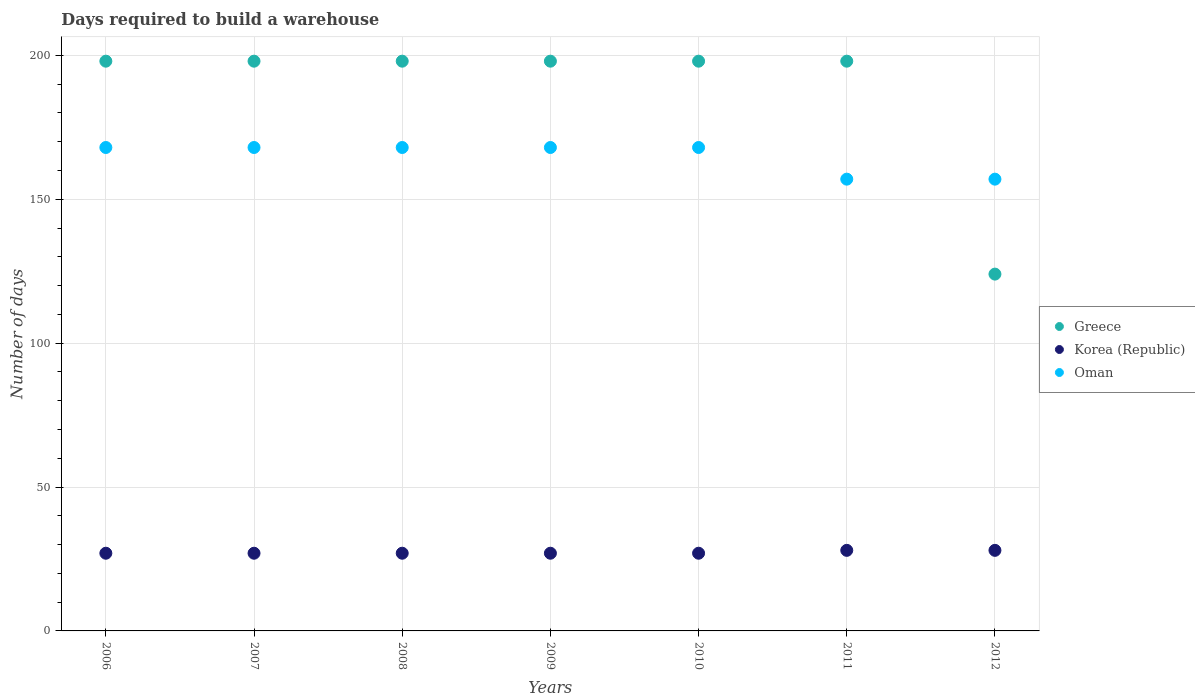How many different coloured dotlines are there?
Your response must be concise. 3. Is the number of dotlines equal to the number of legend labels?
Offer a very short reply. Yes. What is the days required to build a warehouse in in Korea (Republic) in 2009?
Provide a succinct answer. 27. Across all years, what is the maximum days required to build a warehouse in in Oman?
Give a very brief answer. 168. Across all years, what is the minimum days required to build a warehouse in in Greece?
Your answer should be compact. 124. What is the total days required to build a warehouse in in Oman in the graph?
Give a very brief answer. 1154. What is the difference between the days required to build a warehouse in in Greece in 2006 and that in 2010?
Ensure brevity in your answer.  0. What is the difference between the days required to build a warehouse in in Korea (Republic) in 2011 and the days required to build a warehouse in in Oman in 2009?
Make the answer very short. -140. What is the average days required to build a warehouse in in Greece per year?
Offer a terse response. 187.43. In the year 2008, what is the difference between the days required to build a warehouse in in Oman and days required to build a warehouse in in Greece?
Offer a terse response. -30. In how many years, is the days required to build a warehouse in in Greece greater than 40 days?
Provide a short and direct response. 7. What is the ratio of the days required to build a warehouse in in Korea (Republic) in 2007 to that in 2012?
Make the answer very short. 0.96. Is the days required to build a warehouse in in Greece in 2011 less than that in 2012?
Offer a terse response. No. Is the difference between the days required to build a warehouse in in Oman in 2006 and 2011 greater than the difference between the days required to build a warehouse in in Greece in 2006 and 2011?
Provide a short and direct response. Yes. What is the difference between the highest and the second highest days required to build a warehouse in in Korea (Republic)?
Your response must be concise. 0. What is the difference between the highest and the lowest days required to build a warehouse in in Korea (Republic)?
Provide a short and direct response. 1. In how many years, is the days required to build a warehouse in in Korea (Republic) greater than the average days required to build a warehouse in in Korea (Republic) taken over all years?
Keep it short and to the point. 2. Is the sum of the days required to build a warehouse in in Oman in 2008 and 2011 greater than the maximum days required to build a warehouse in in Greece across all years?
Ensure brevity in your answer.  Yes. Is it the case that in every year, the sum of the days required to build a warehouse in in Oman and days required to build a warehouse in in Korea (Republic)  is greater than the days required to build a warehouse in in Greece?
Your response must be concise. No. Is the days required to build a warehouse in in Oman strictly greater than the days required to build a warehouse in in Korea (Republic) over the years?
Keep it short and to the point. Yes. How many dotlines are there?
Offer a terse response. 3. How many years are there in the graph?
Your response must be concise. 7. Does the graph contain any zero values?
Your answer should be very brief. No. Where does the legend appear in the graph?
Make the answer very short. Center right. How are the legend labels stacked?
Ensure brevity in your answer.  Vertical. What is the title of the graph?
Your answer should be compact. Days required to build a warehouse. Does "Brazil" appear as one of the legend labels in the graph?
Provide a short and direct response. No. What is the label or title of the X-axis?
Provide a short and direct response. Years. What is the label or title of the Y-axis?
Your answer should be very brief. Number of days. What is the Number of days in Greece in 2006?
Your answer should be very brief. 198. What is the Number of days of Korea (Republic) in 2006?
Your answer should be very brief. 27. What is the Number of days of Oman in 2006?
Keep it short and to the point. 168. What is the Number of days of Greece in 2007?
Your response must be concise. 198. What is the Number of days of Korea (Republic) in 2007?
Give a very brief answer. 27. What is the Number of days of Oman in 2007?
Your answer should be compact. 168. What is the Number of days of Greece in 2008?
Your answer should be compact. 198. What is the Number of days of Korea (Republic) in 2008?
Offer a very short reply. 27. What is the Number of days in Oman in 2008?
Provide a succinct answer. 168. What is the Number of days in Greece in 2009?
Make the answer very short. 198. What is the Number of days of Oman in 2009?
Your response must be concise. 168. What is the Number of days of Greece in 2010?
Give a very brief answer. 198. What is the Number of days of Oman in 2010?
Keep it short and to the point. 168. What is the Number of days of Greece in 2011?
Your answer should be very brief. 198. What is the Number of days of Korea (Republic) in 2011?
Offer a very short reply. 28. What is the Number of days in Oman in 2011?
Give a very brief answer. 157. What is the Number of days of Greece in 2012?
Provide a short and direct response. 124. What is the Number of days in Oman in 2012?
Offer a very short reply. 157. Across all years, what is the maximum Number of days in Greece?
Make the answer very short. 198. Across all years, what is the maximum Number of days of Korea (Republic)?
Offer a very short reply. 28. Across all years, what is the maximum Number of days in Oman?
Offer a very short reply. 168. Across all years, what is the minimum Number of days in Greece?
Keep it short and to the point. 124. Across all years, what is the minimum Number of days of Oman?
Ensure brevity in your answer.  157. What is the total Number of days of Greece in the graph?
Ensure brevity in your answer.  1312. What is the total Number of days in Korea (Republic) in the graph?
Offer a terse response. 191. What is the total Number of days in Oman in the graph?
Offer a terse response. 1154. What is the difference between the Number of days in Korea (Republic) in 2006 and that in 2007?
Ensure brevity in your answer.  0. What is the difference between the Number of days in Korea (Republic) in 2006 and that in 2008?
Your answer should be compact. 0. What is the difference between the Number of days in Oman in 2006 and that in 2008?
Your response must be concise. 0. What is the difference between the Number of days of Oman in 2006 and that in 2009?
Ensure brevity in your answer.  0. What is the difference between the Number of days in Greece in 2006 and that in 2010?
Offer a very short reply. 0. What is the difference between the Number of days in Oman in 2006 and that in 2010?
Provide a succinct answer. 0. What is the difference between the Number of days in Greece in 2006 and that in 2011?
Offer a terse response. 0. What is the difference between the Number of days in Greece in 2006 and that in 2012?
Make the answer very short. 74. What is the difference between the Number of days of Korea (Republic) in 2006 and that in 2012?
Offer a very short reply. -1. What is the difference between the Number of days in Oman in 2006 and that in 2012?
Ensure brevity in your answer.  11. What is the difference between the Number of days in Oman in 2007 and that in 2008?
Make the answer very short. 0. What is the difference between the Number of days of Korea (Republic) in 2007 and that in 2009?
Make the answer very short. 0. What is the difference between the Number of days in Oman in 2007 and that in 2010?
Keep it short and to the point. 0. What is the difference between the Number of days of Korea (Republic) in 2007 and that in 2011?
Offer a terse response. -1. What is the difference between the Number of days of Oman in 2007 and that in 2011?
Your answer should be very brief. 11. What is the difference between the Number of days of Greece in 2007 and that in 2012?
Ensure brevity in your answer.  74. What is the difference between the Number of days in Oman in 2007 and that in 2012?
Ensure brevity in your answer.  11. What is the difference between the Number of days in Oman in 2008 and that in 2009?
Your response must be concise. 0. What is the difference between the Number of days of Korea (Republic) in 2008 and that in 2010?
Your response must be concise. 0. What is the difference between the Number of days of Oman in 2008 and that in 2010?
Offer a terse response. 0. What is the difference between the Number of days in Greece in 2008 and that in 2011?
Provide a short and direct response. 0. What is the difference between the Number of days in Oman in 2008 and that in 2012?
Provide a succinct answer. 11. What is the difference between the Number of days of Korea (Republic) in 2009 and that in 2010?
Ensure brevity in your answer.  0. What is the difference between the Number of days in Oman in 2009 and that in 2010?
Your answer should be compact. 0. What is the difference between the Number of days of Greece in 2009 and that in 2011?
Offer a very short reply. 0. What is the difference between the Number of days in Oman in 2009 and that in 2011?
Give a very brief answer. 11. What is the difference between the Number of days in Greece in 2009 and that in 2012?
Keep it short and to the point. 74. What is the difference between the Number of days in Korea (Republic) in 2009 and that in 2012?
Offer a terse response. -1. What is the difference between the Number of days of Greece in 2010 and that in 2011?
Your answer should be compact. 0. What is the difference between the Number of days in Korea (Republic) in 2010 and that in 2012?
Provide a succinct answer. -1. What is the difference between the Number of days of Oman in 2010 and that in 2012?
Your answer should be compact. 11. What is the difference between the Number of days of Korea (Republic) in 2011 and that in 2012?
Offer a terse response. 0. What is the difference between the Number of days in Greece in 2006 and the Number of days in Korea (Republic) in 2007?
Offer a very short reply. 171. What is the difference between the Number of days of Korea (Republic) in 2006 and the Number of days of Oman in 2007?
Make the answer very short. -141. What is the difference between the Number of days in Greece in 2006 and the Number of days in Korea (Republic) in 2008?
Your response must be concise. 171. What is the difference between the Number of days in Greece in 2006 and the Number of days in Oman in 2008?
Your answer should be very brief. 30. What is the difference between the Number of days in Korea (Republic) in 2006 and the Number of days in Oman in 2008?
Provide a short and direct response. -141. What is the difference between the Number of days of Greece in 2006 and the Number of days of Korea (Republic) in 2009?
Your answer should be very brief. 171. What is the difference between the Number of days in Greece in 2006 and the Number of days in Oman in 2009?
Provide a short and direct response. 30. What is the difference between the Number of days in Korea (Republic) in 2006 and the Number of days in Oman in 2009?
Your answer should be very brief. -141. What is the difference between the Number of days of Greece in 2006 and the Number of days of Korea (Republic) in 2010?
Your response must be concise. 171. What is the difference between the Number of days of Greece in 2006 and the Number of days of Oman in 2010?
Offer a terse response. 30. What is the difference between the Number of days of Korea (Republic) in 2006 and the Number of days of Oman in 2010?
Your answer should be compact. -141. What is the difference between the Number of days in Greece in 2006 and the Number of days in Korea (Republic) in 2011?
Your response must be concise. 170. What is the difference between the Number of days in Greece in 2006 and the Number of days in Oman in 2011?
Your answer should be very brief. 41. What is the difference between the Number of days of Korea (Republic) in 2006 and the Number of days of Oman in 2011?
Your response must be concise. -130. What is the difference between the Number of days of Greece in 2006 and the Number of days of Korea (Republic) in 2012?
Provide a short and direct response. 170. What is the difference between the Number of days of Greece in 2006 and the Number of days of Oman in 2012?
Provide a succinct answer. 41. What is the difference between the Number of days in Korea (Republic) in 2006 and the Number of days in Oman in 2012?
Provide a succinct answer. -130. What is the difference between the Number of days in Greece in 2007 and the Number of days in Korea (Republic) in 2008?
Your answer should be compact. 171. What is the difference between the Number of days in Greece in 2007 and the Number of days in Oman in 2008?
Keep it short and to the point. 30. What is the difference between the Number of days in Korea (Republic) in 2007 and the Number of days in Oman in 2008?
Provide a succinct answer. -141. What is the difference between the Number of days of Greece in 2007 and the Number of days of Korea (Republic) in 2009?
Give a very brief answer. 171. What is the difference between the Number of days of Korea (Republic) in 2007 and the Number of days of Oman in 2009?
Provide a succinct answer. -141. What is the difference between the Number of days in Greece in 2007 and the Number of days in Korea (Republic) in 2010?
Ensure brevity in your answer.  171. What is the difference between the Number of days in Greece in 2007 and the Number of days in Oman in 2010?
Offer a very short reply. 30. What is the difference between the Number of days in Korea (Republic) in 2007 and the Number of days in Oman in 2010?
Make the answer very short. -141. What is the difference between the Number of days in Greece in 2007 and the Number of days in Korea (Republic) in 2011?
Your response must be concise. 170. What is the difference between the Number of days of Korea (Republic) in 2007 and the Number of days of Oman in 2011?
Your answer should be compact. -130. What is the difference between the Number of days in Greece in 2007 and the Number of days in Korea (Republic) in 2012?
Your answer should be compact. 170. What is the difference between the Number of days of Greece in 2007 and the Number of days of Oman in 2012?
Offer a very short reply. 41. What is the difference between the Number of days in Korea (Republic) in 2007 and the Number of days in Oman in 2012?
Make the answer very short. -130. What is the difference between the Number of days in Greece in 2008 and the Number of days in Korea (Republic) in 2009?
Offer a very short reply. 171. What is the difference between the Number of days in Greece in 2008 and the Number of days in Oman in 2009?
Offer a very short reply. 30. What is the difference between the Number of days in Korea (Republic) in 2008 and the Number of days in Oman in 2009?
Make the answer very short. -141. What is the difference between the Number of days in Greece in 2008 and the Number of days in Korea (Republic) in 2010?
Your answer should be very brief. 171. What is the difference between the Number of days in Greece in 2008 and the Number of days in Oman in 2010?
Make the answer very short. 30. What is the difference between the Number of days of Korea (Republic) in 2008 and the Number of days of Oman in 2010?
Provide a succinct answer. -141. What is the difference between the Number of days in Greece in 2008 and the Number of days in Korea (Republic) in 2011?
Provide a succinct answer. 170. What is the difference between the Number of days of Greece in 2008 and the Number of days of Oman in 2011?
Your answer should be very brief. 41. What is the difference between the Number of days in Korea (Republic) in 2008 and the Number of days in Oman in 2011?
Make the answer very short. -130. What is the difference between the Number of days of Greece in 2008 and the Number of days of Korea (Republic) in 2012?
Provide a succinct answer. 170. What is the difference between the Number of days of Greece in 2008 and the Number of days of Oman in 2012?
Your answer should be very brief. 41. What is the difference between the Number of days in Korea (Republic) in 2008 and the Number of days in Oman in 2012?
Ensure brevity in your answer.  -130. What is the difference between the Number of days of Greece in 2009 and the Number of days of Korea (Republic) in 2010?
Your response must be concise. 171. What is the difference between the Number of days in Greece in 2009 and the Number of days in Oman in 2010?
Ensure brevity in your answer.  30. What is the difference between the Number of days of Korea (Republic) in 2009 and the Number of days of Oman in 2010?
Your answer should be compact. -141. What is the difference between the Number of days in Greece in 2009 and the Number of days in Korea (Republic) in 2011?
Ensure brevity in your answer.  170. What is the difference between the Number of days of Greece in 2009 and the Number of days of Oman in 2011?
Keep it short and to the point. 41. What is the difference between the Number of days in Korea (Republic) in 2009 and the Number of days in Oman in 2011?
Your answer should be very brief. -130. What is the difference between the Number of days in Greece in 2009 and the Number of days in Korea (Republic) in 2012?
Your answer should be compact. 170. What is the difference between the Number of days in Greece in 2009 and the Number of days in Oman in 2012?
Provide a succinct answer. 41. What is the difference between the Number of days of Korea (Republic) in 2009 and the Number of days of Oman in 2012?
Ensure brevity in your answer.  -130. What is the difference between the Number of days in Greece in 2010 and the Number of days in Korea (Republic) in 2011?
Keep it short and to the point. 170. What is the difference between the Number of days in Greece in 2010 and the Number of days in Oman in 2011?
Offer a terse response. 41. What is the difference between the Number of days in Korea (Republic) in 2010 and the Number of days in Oman in 2011?
Offer a terse response. -130. What is the difference between the Number of days in Greece in 2010 and the Number of days in Korea (Republic) in 2012?
Your response must be concise. 170. What is the difference between the Number of days in Greece in 2010 and the Number of days in Oman in 2012?
Offer a very short reply. 41. What is the difference between the Number of days of Korea (Republic) in 2010 and the Number of days of Oman in 2012?
Provide a short and direct response. -130. What is the difference between the Number of days in Greece in 2011 and the Number of days in Korea (Republic) in 2012?
Ensure brevity in your answer.  170. What is the difference between the Number of days of Korea (Republic) in 2011 and the Number of days of Oman in 2012?
Ensure brevity in your answer.  -129. What is the average Number of days in Greece per year?
Provide a succinct answer. 187.43. What is the average Number of days of Korea (Republic) per year?
Provide a short and direct response. 27.29. What is the average Number of days of Oman per year?
Ensure brevity in your answer.  164.86. In the year 2006, what is the difference between the Number of days in Greece and Number of days in Korea (Republic)?
Give a very brief answer. 171. In the year 2006, what is the difference between the Number of days in Greece and Number of days in Oman?
Offer a terse response. 30. In the year 2006, what is the difference between the Number of days in Korea (Republic) and Number of days in Oman?
Your response must be concise. -141. In the year 2007, what is the difference between the Number of days in Greece and Number of days in Korea (Republic)?
Provide a short and direct response. 171. In the year 2007, what is the difference between the Number of days in Greece and Number of days in Oman?
Make the answer very short. 30. In the year 2007, what is the difference between the Number of days of Korea (Republic) and Number of days of Oman?
Keep it short and to the point. -141. In the year 2008, what is the difference between the Number of days in Greece and Number of days in Korea (Republic)?
Make the answer very short. 171. In the year 2008, what is the difference between the Number of days of Korea (Republic) and Number of days of Oman?
Give a very brief answer. -141. In the year 2009, what is the difference between the Number of days of Greece and Number of days of Korea (Republic)?
Keep it short and to the point. 171. In the year 2009, what is the difference between the Number of days in Greece and Number of days in Oman?
Keep it short and to the point. 30. In the year 2009, what is the difference between the Number of days in Korea (Republic) and Number of days in Oman?
Offer a very short reply. -141. In the year 2010, what is the difference between the Number of days of Greece and Number of days of Korea (Republic)?
Make the answer very short. 171. In the year 2010, what is the difference between the Number of days in Greece and Number of days in Oman?
Provide a short and direct response. 30. In the year 2010, what is the difference between the Number of days of Korea (Republic) and Number of days of Oman?
Make the answer very short. -141. In the year 2011, what is the difference between the Number of days of Greece and Number of days of Korea (Republic)?
Your answer should be compact. 170. In the year 2011, what is the difference between the Number of days in Greece and Number of days in Oman?
Your answer should be compact. 41. In the year 2011, what is the difference between the Number of days of Korea (Republic) and Number of days of Oman?
Give a very brief answer. -129. In the year 2012, what is the difference between the Number of days of Greece and Number of days of Korea (Republic)?
Provide a succinct answer. 96. In the year 2012, what is the difference between the Number of days in Greece and Number of days in Oman?
Give a very brief answer. -33. In the year 2012, what is the difference between the Number of days in Korea (Republic) and Number of days in Oman?
Keep it short and to the point. -129. What is the ratio of the Number of days of Oman in 2006 to that in 2007?
Give a very brief answer. 1. What is the ratio of the Number of days in Greece in 2006 to that in 2008?
Your answer should be compact. 1. What is the ratio of the Number of days in Korea (Republic) in 2006 to that in 2008?
Your answer should be very brief. 1. What is the ratio of the Number of days of Korea (Republic) in 2006 to that in 2011?
Your response must be concise. 0.96. What is the ratio of the Number of days in Oman in 2006 to that in 2011?
Your response must be concise. 1.07. What is the ratio of the Number of days of Greece in 2006 to that in 2012?
Your response must be concise. 1.6. What is the ratio of the Number of days of Korea (Republic) in 2006 to that in 2012?
Make the answer very short. 0.96. What is the ratio of the Number of days of Oman in 2006 to that in 2012?
Provide a short and direct response. 1.07. What is the ratio of the Number of days of Korea (Republic) in 2007 to that in 2008?
Offer a very short reply. 1. What is the ratio of the Number of days in Oman in 2007 to that in 2008?
Make the answer very short. 1. What is the ratio of the Number of days of Oman in 2007 to that in 2009?
Make the answer very short. 1. What is the ratio of the Number of days in Korea (Republic) in 2007 to that in 2010?
Keep it short and to the point. 1. What is the ratio of the Number of days in Oman in 2007 to that in 2011?
Keep it short and to the point. 1.07. What is the ratio of the Number of days in Greece in 2007 to that in 2012?
Provide a short and direct response. 1.6. What is the ratio of the Number of days in Oman in 2007 to that in 2012?
Your answer should be very brief. 1.07. What is the ratio of the Number of days of Greece in 2008 to that in 2009?
Provide a short and direct response. 1. What is the ratio of the Number of days of Oman in 2008 to that in 2009?
Your answer should be compact. 1. What is the ratio of the Number of days in Korea (Republic) in 2008 to that in 2010?
Provide a succinct answer. 1. What is the ratio of the Number of days in Greece in 2008 to that in 2011?
Your response must be concise. 1. What is the ratio of the Number of days in Oman in 2008 to that in 2011?
Provide a succinct answer. 1.07. What is the ratio of the Number of days in Greece in 2008 to that in 2012?
Make the answer very short. 1.6. What is the ratio of the Number of days in Oman in 2008 to that in 2012?
Offer a very short reply. 1.07. What is the ratio of the Number of days in Greece in 2009 to that in 2010?
Your answer should be very brief. 1. What is the ratio of the Number of days of Oman in 2009 to that in 2010?
Your answer should be very brief. 1. What is the ratio of the Number of days in Greece in 2009 to that in 2011?
Your answer should be very brief. 1. What is the ratio of the Number of days of Oman in 2009 to that in 2011?
Give a very brief answer. 1.07. What is the ratio of the Number of days in Greece in 2009 to that in 2012?
Provide a succinct answer. 1.6. What is the ratio of the Number of days in Korea (Republic) in 2009 to that in 2012?
Offer a terse response. 0.96. What is the ratio of the Number of days of Oman in 2009 to that in 2012?
Your response must be concise. 1.07. What is the ratio of the Number of days in Korea (Republic) in 2010 to that in 2011?
Provide a succinct answer. 0.96. What is the ratio of the Number of days in Oman in 2010 to that in 2011?
Offer a terse response. 1.07. What is the ratio of the Number of days in Greece in 2010 to that in 2012?
Make the answer very short. 1.6. What is the ratio of the Number of days of Oman in 2010 to that in 2012?
Your answer should be very brief. 1.07. What is the ratio of the Number of days in Greece in 2011 to that in 2012?
Give a very brief answer. 1.6. What is the ratio of the Number of days in Oman in 2011 to that in 2012?
Your answer should be compact. 1. What is the difference between the highest and the second highest Number of days of Greece?
Offer a very short reply. 0. What is the difference between the highest and the lowest Number of days in Greece?
Offer a terse response. 74. What is the difference between the highest and the lowest Number of days in Korea (Republic)?
Keep it short and to the point. 1. What is the difference between the highest and the lowest Number of days in Oman?
Provide a short and direct response. 11. 